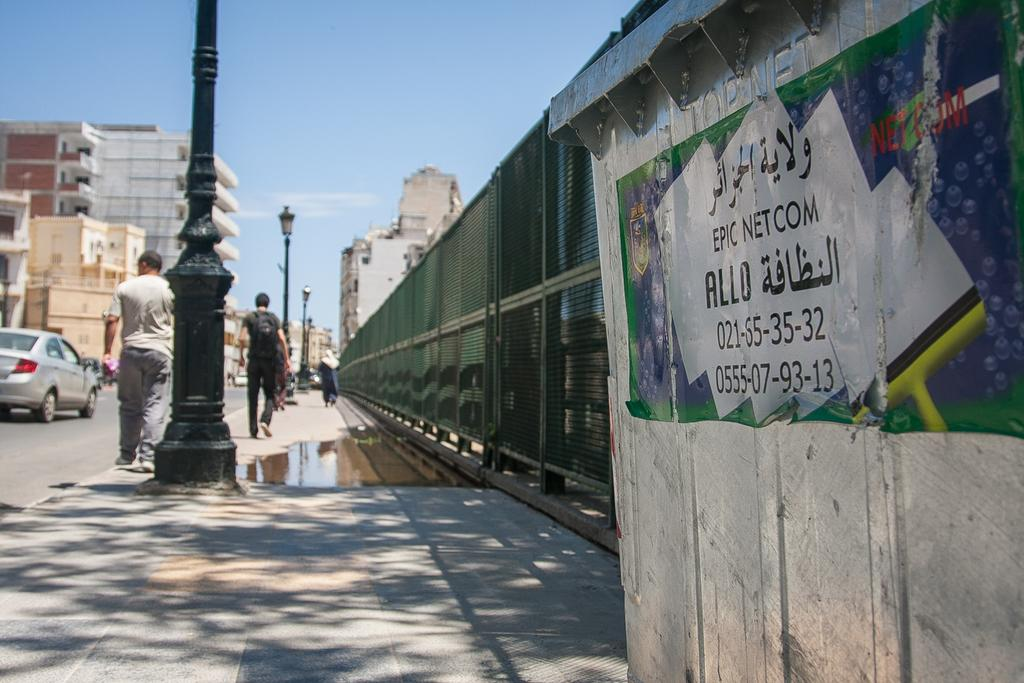<image>
Render a clear and concise summary of the photo. A view down a city street with people walking down it past a telecoms box whih has arabic writing and also the words Epic Netcom on it. 